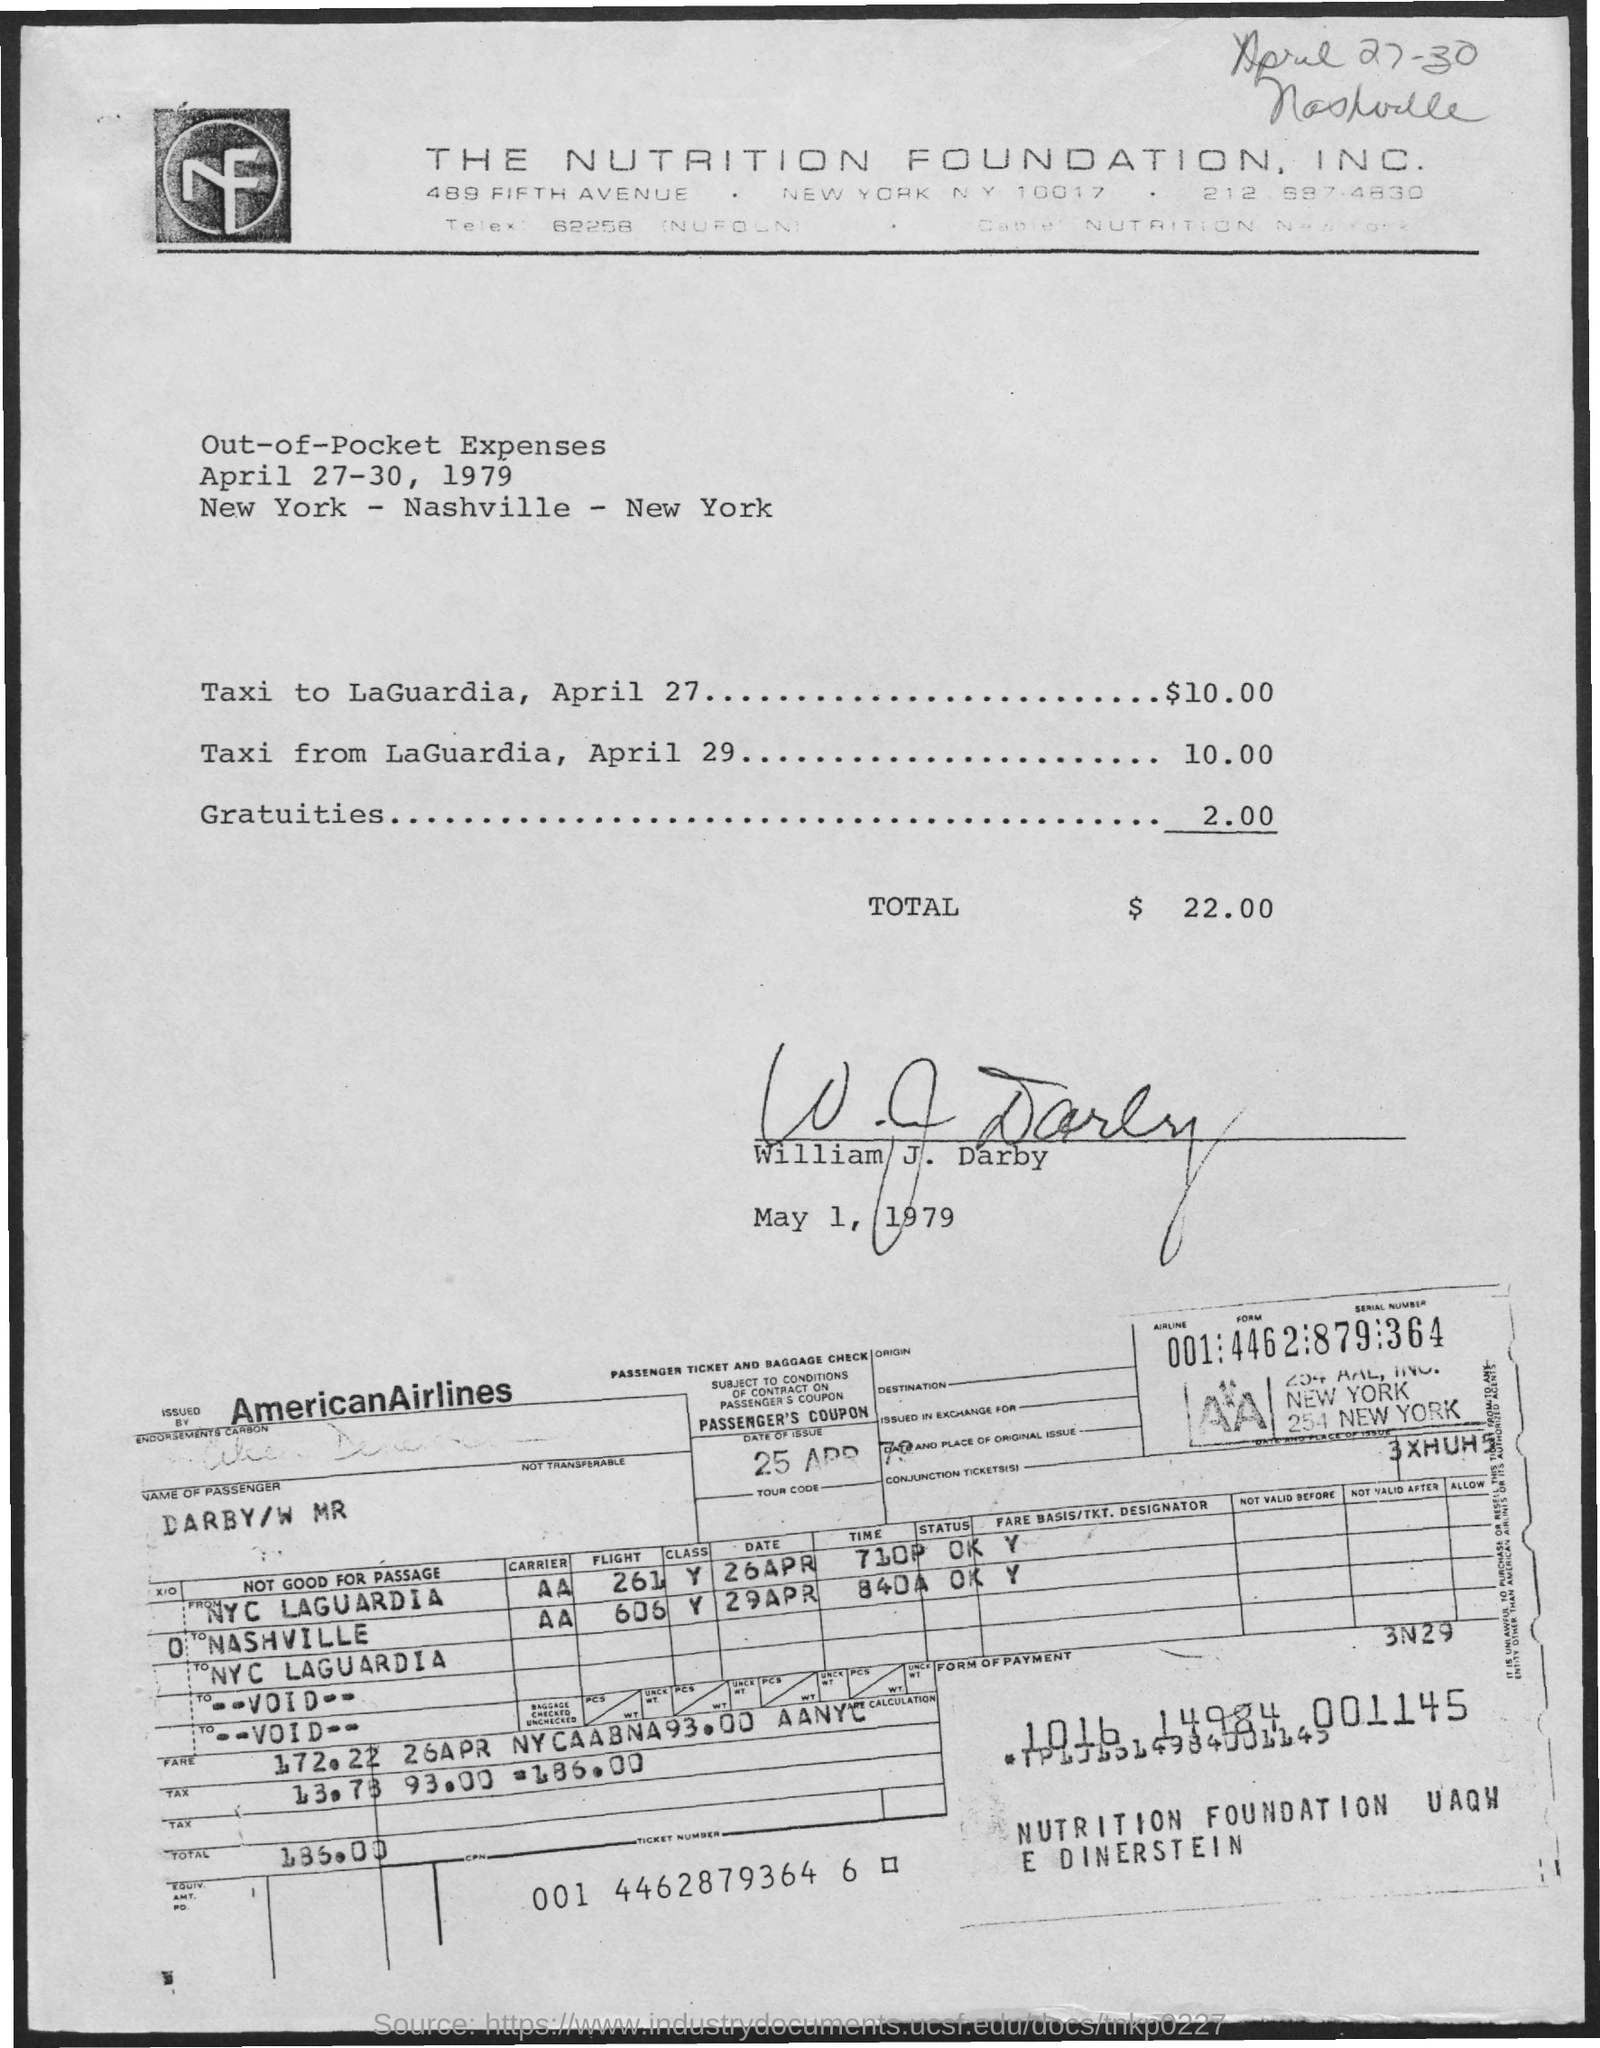Which Airline ticket is provided?
Ensure brevity in your answer.  Americanairlines. 